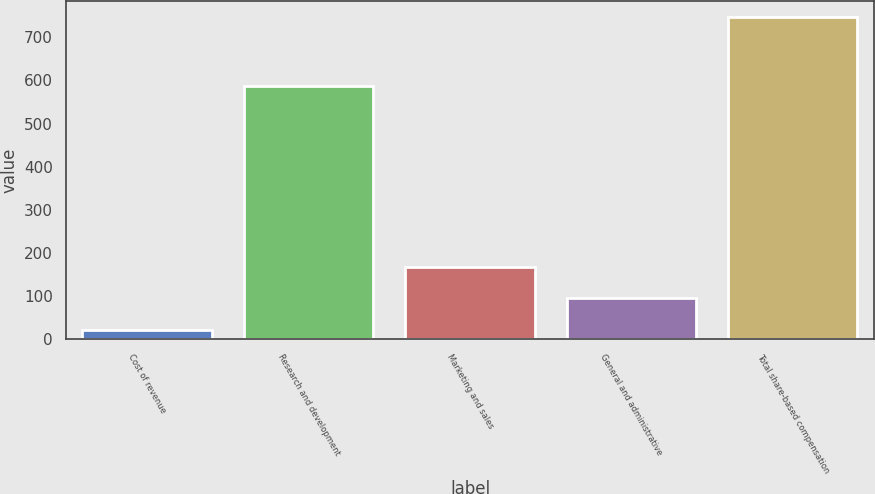Convert chart to OTSL. <chart><loc_0><loc_0><loc_500><loc_500><bar_chart><fcel>Cost of revenue<fcel>Research and development<fcel>Marketing and sales<fcel>General and administrative<fcel>Total share-based compensation<nl><fcel>22<fcel>586<fcel>166.8<fcel>94.4<fcel>746<nl></chart> 